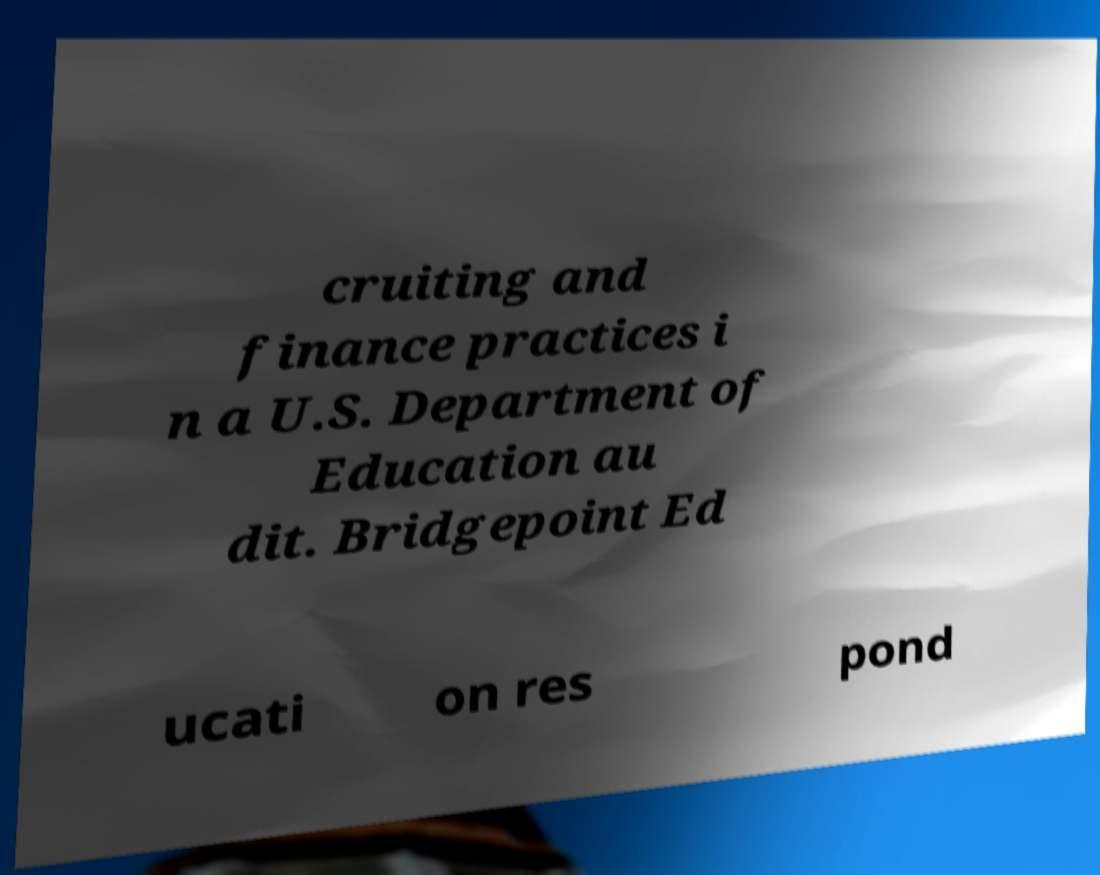What messages or text are displayed in this image? I need them in a readable, typed format. cruiting and finance practices i n a U.S. Department of Education au dit. Bridgepoint Ed ucati on res pond 